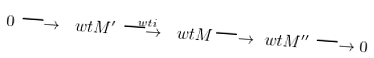Convert formula to latex. <formula><loc_0><loc_0><loc_500><loc_500>0 \longrightarrow \ w t { M } ^ { \prime } \stackrel { \ w t { i } } { \longrightarrow } \ w t { M } { \longrightarrow } \ w t { M } ^ { \prime \prime } \longrightarrow 0</formula> 